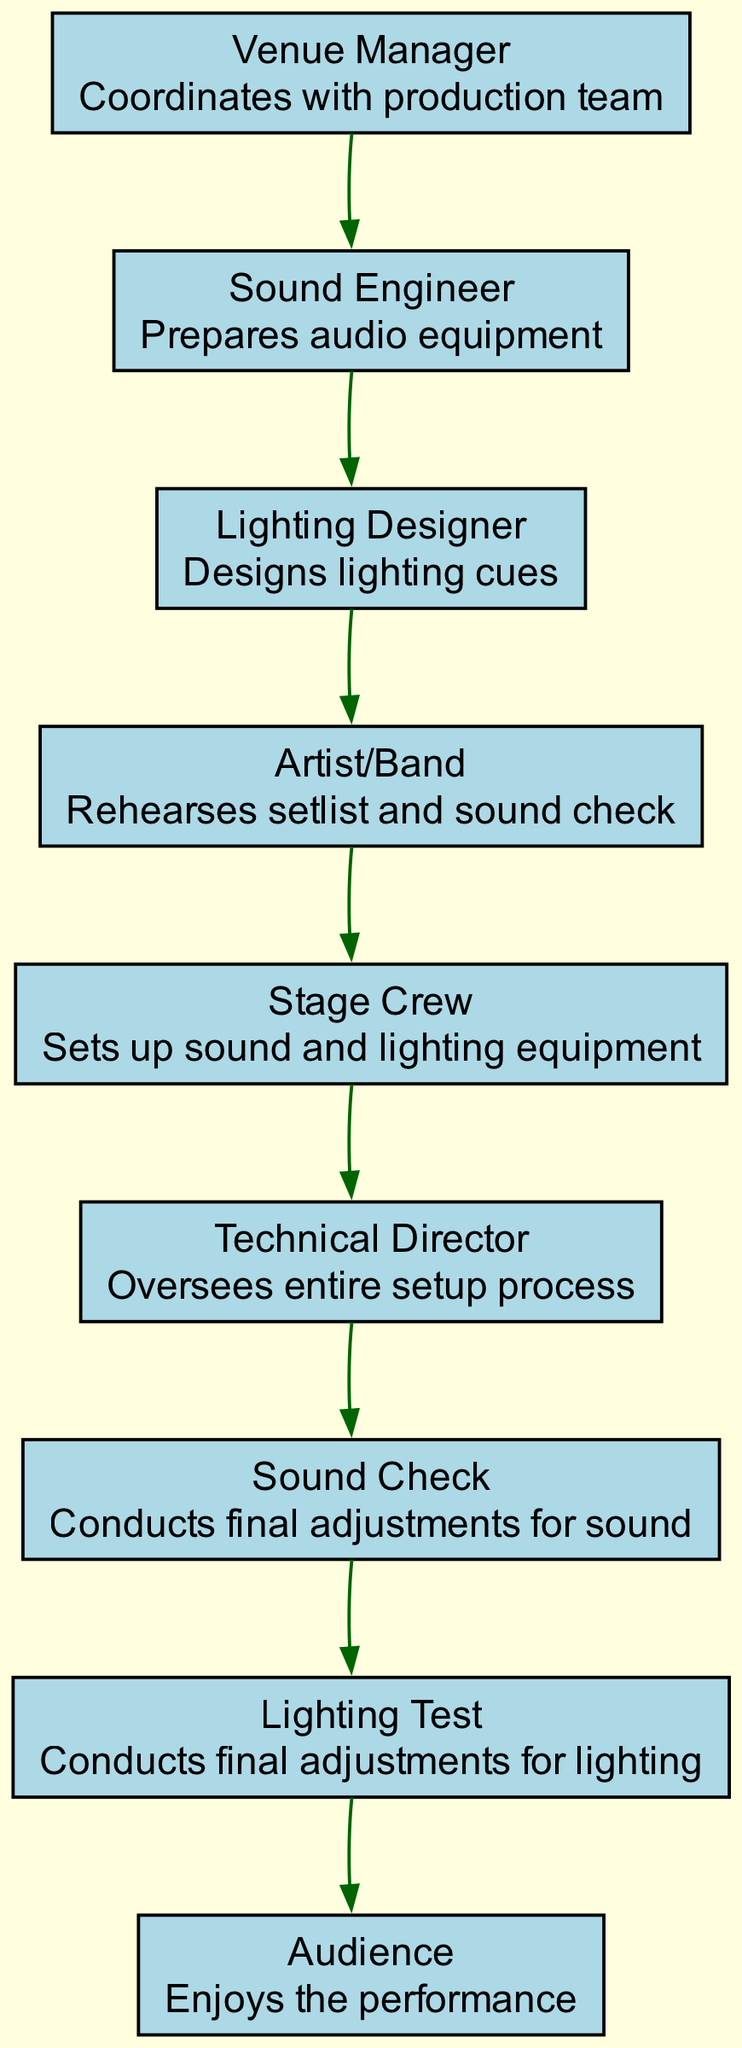What is the first action in the sequence? The first action in the sequence is performed by the Venue Manager who coordinates with the production team. This can be found at the beginning of the diagram where the Venue Manager is noted first.
Answer: Coordinates with production team How many nodes are in the diagram? The nodes in the diagram represent each of the distinct roles or actions involved in the setup process. Counting them reveals there are 9 nodes in total.
Answer: 9 What is the action of the Lighting Designer? The Lighting Designer is responsible for designing the lighting cues. This is stated directly beside the Lighting Designer's node in the diagram.
Answer: Designs lighting cues Who oversees the setup process? The diagram indicates that the Technical Director oversees the entire setup process. This is shown in the action associated with the Technical Director node.
Answer: Oversees entire setup process What follows the Sound Engineer's action in the sequence? The action that follows the Sound Engineer, who prepares the audio equipment, is performed by the Lighting Designer, who designs the lighting cues next in the flow of the diagram.
Answer: Designs lighting cues Which action is taken first by the Artist/Band? The Artist/Band first rehearses the setlist and sound check as per the specified action associated with that role in the diagram.
Answer: Rehearses setlist and sound check What is conducted after the Stage Crew's action? After the Stage Crew sets up the sound and lighting equipment, the next actions are the Sound Check and Lighting Test, which make adjustments to audio and lighting, respectively.
Answer: Conducts final adjustments for sound How does the audience relate to the performance in this sequence? The audience enjoys the performance, which is the final action in the sequence diagram, indicating their role as recipients of the culmination of all prior efforts.
Answer: Enjoys the performance Which two groups are involved in conducting final adjustments? The Sound Engineer and Lighting Designer are both responsible for conducting final adjustments, specifically to sound and lighting, which immediately follows their respective setup actions.
Answer: Sound Check and Lighting Test 